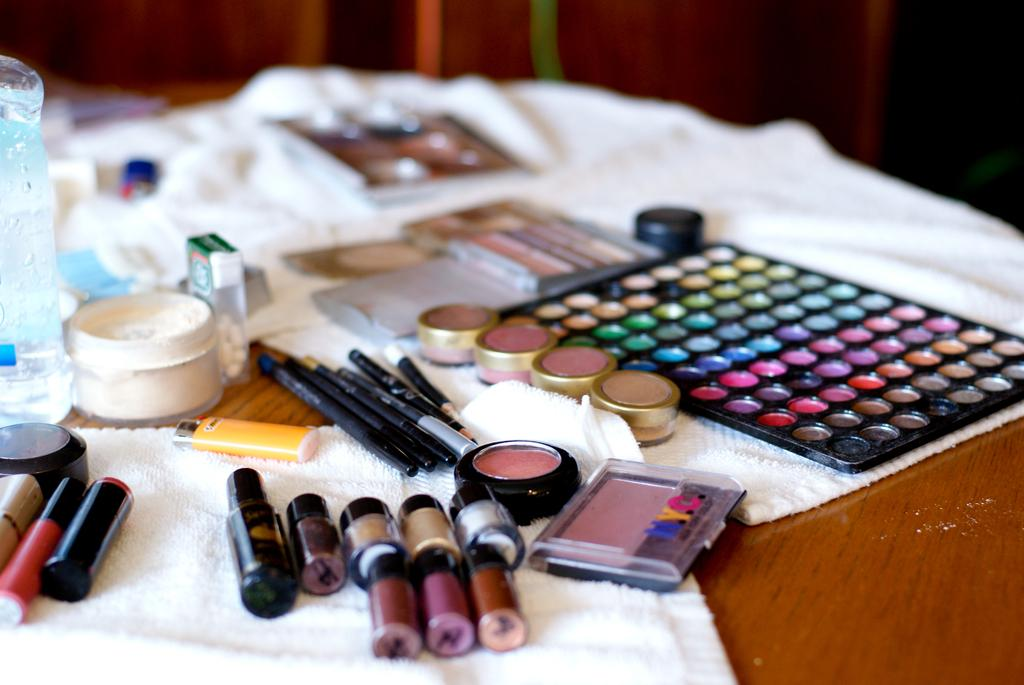What type of items can be seen in the image? There are cosmetics in the image. What is the color of the surface on which the clothes are placed? The clothes are on a brown surface. How are the cosmetics arranged in the image? The cosmetics are placed on the white clothes. What can be observed about the background of the image? The background of the image is blurred. How many passengers are visible in the image? There are no passengers present in the image; it features cosmetics on white clothes placed on a brown surface. What type of medical advice can be obtained from the doctor in the image? There is no doctor present in the image; it features cosmetics on white clothes placed on a brown surface. 